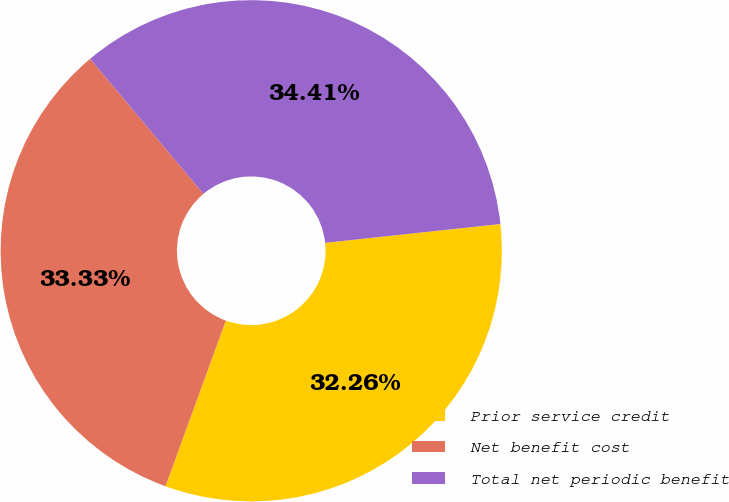<chart> <loc_0><loc_0><loc_500><loc_500><pie_chart><fcel>Prior service credit<fcel>Net benefit cost<fcel>Total net periodic benefit<nl><fcel>32.26%<fcel>33.33%<fcel>34.41%<nl></chart> 